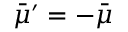<formula> <loc_0><loc_0><loc_500><loc_500>\bar { \mu } ^ { \prime } = - \bar { \mu }</formula> 